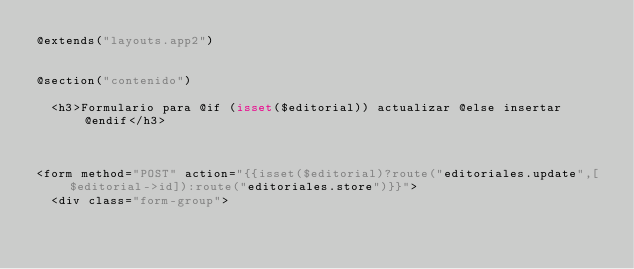<code> <loc_0><loc_0><loc_500><loc_500><_PHP_>@extends("layouts.app2")


@section("contenido")

	<h3>Formulario para @if (isset($editorial)) actualizar @else insertar @endif</h3>

    

<form method="POST" action="{{isset($editorial)?route("editoriales.update",[$editorial->id]):route("editoriales.store")}}">
  <div class="form-group"></code> 